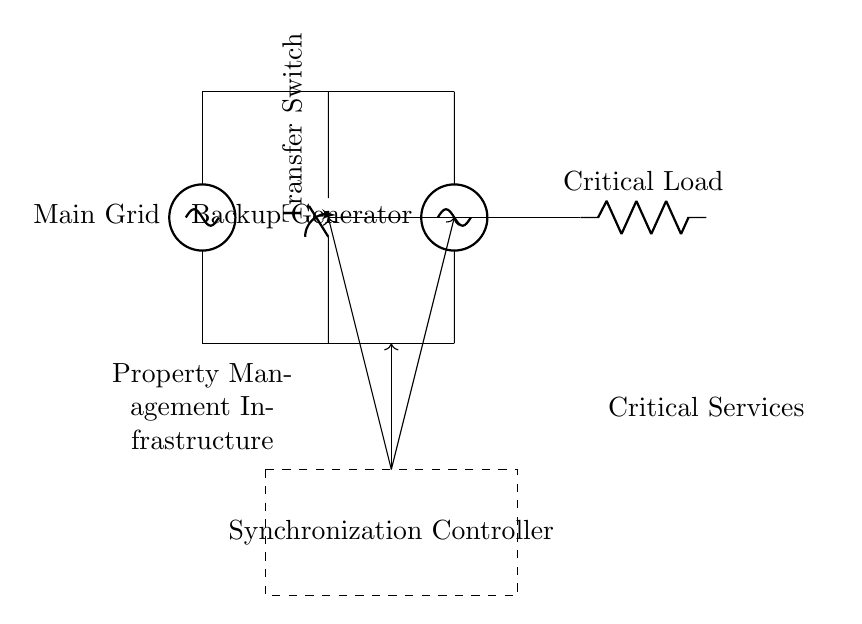What is the main power source in this circuit? The main power source is labeled as "Main Grid" on the left side of the diagram. It indicates the primary supply of electricity for the system.
Answer: Main Grid What component is responsible for switching between power sources? The component responsible for switching is the "Transfer Switch," located between the Main Grid and Backup Generator in the diagram. It governs which power source is connected to the critical load.
Answer: Transfer Switch What is the function of the Synchronization Controller? The Synchronization Controller's role is to manage the synchronization between the Main Grid and Backup Generator so that they operate seamlessly when switching occurs. This ensures no interruption in power supply to the critical load.
Answer: Managing synchronization How many main components are connected to the Critical Load? There are two main components connected to the Critical Load: the Main Grid and the Backup Generator, both of which can supply power as needed.
Answer: Two What type of load is depicted in the circuit? The load depicted in the circuit is labeled as "Critical Load," indicating that it represents essential services that require continuous power supply during outages.
Answer: Critical Load What does the dashed rectangle represent in the diagram? The dashed rectangle encompasses the "Synchronization Controller," which indicates that it is a distinct unit responsible for controlling the synchronization of the power sources in the circuit.
Answer: Synchronization Controller What is indicated by the arrows originating from the Synchronization Controller? The arrows indicate the flow of control signals from the Synchronization Controller to both the Transfer Switch and the output line to the Critical Load, which suggest that it manages power source selection and supply.
Answer: Flow of control signals 